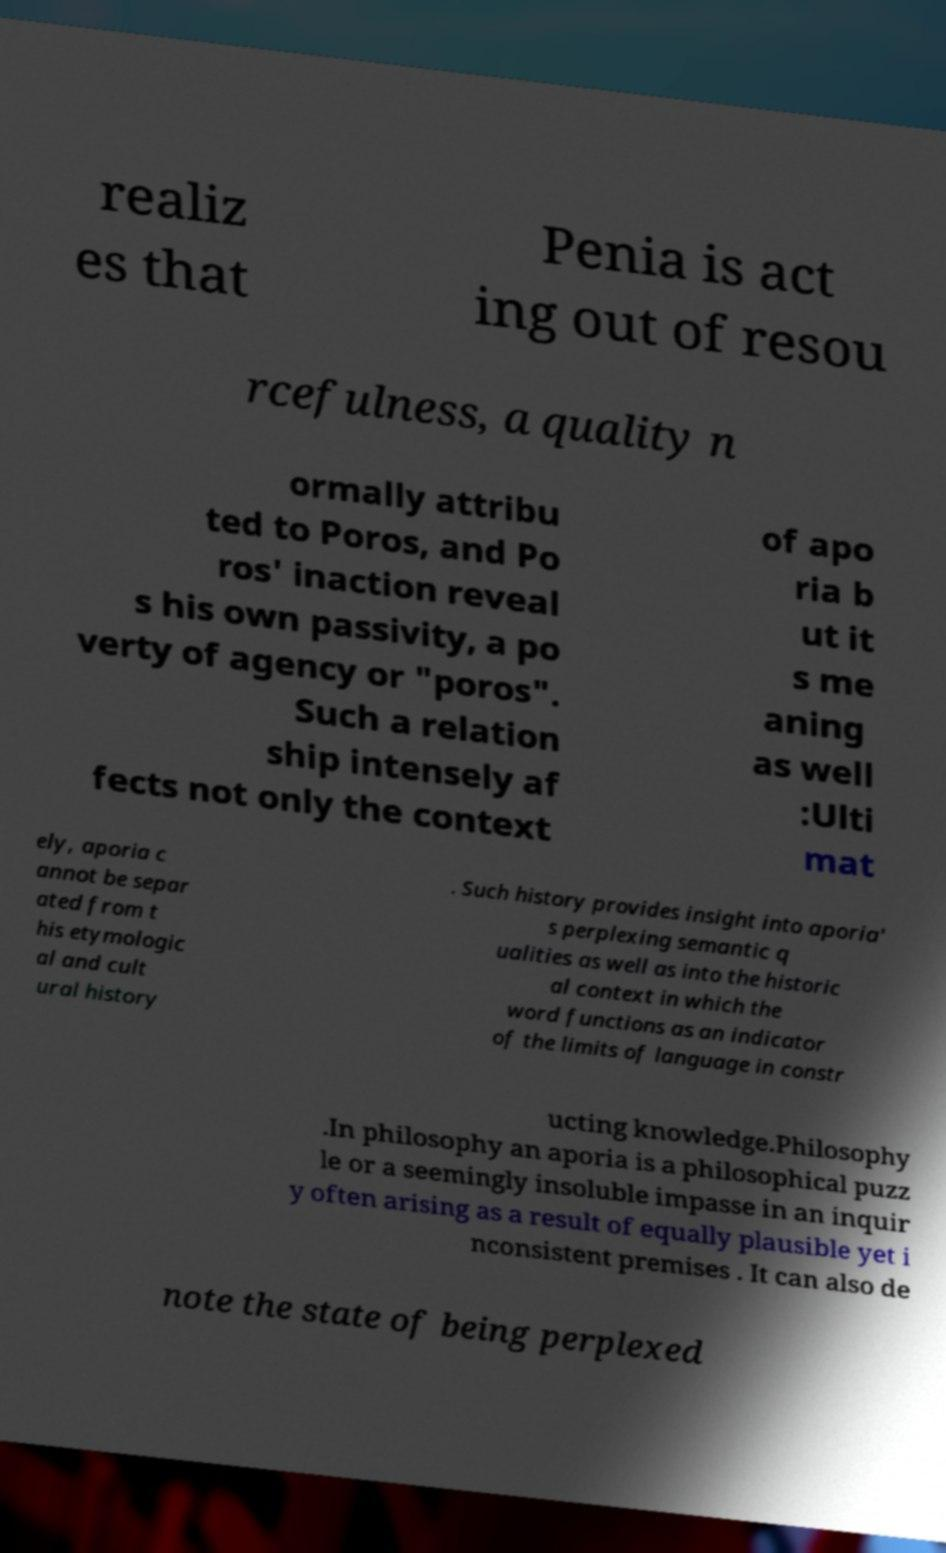Could you extract and type out the text from this image? realiz es that Penia is act ing out of resou rcefulness, a quality n ormally attribu ted to Poros, and Po ros' inaction reveal s his own passivity, a po verty of agency or "poros". Such a relation ship intensely af fects not only the context of apo ria b ut it s me aning as well :Ulti mat ely, aporia c annot be separ ated from t his etymologic al and cult ural history . Such history provides insight into aporia' s perplexing semantic q ualities as well as into the historic al context in which the word functions as an indicator of the limits of language in constr ucting knowledge.Philosophy .In philosophy an aporia is a philosophical puzz le or a seemingly insoluble impasse in an inquir y often arising as a result of equally plausible yet i nconsistent premises . It can also de note the state of being perplexed 